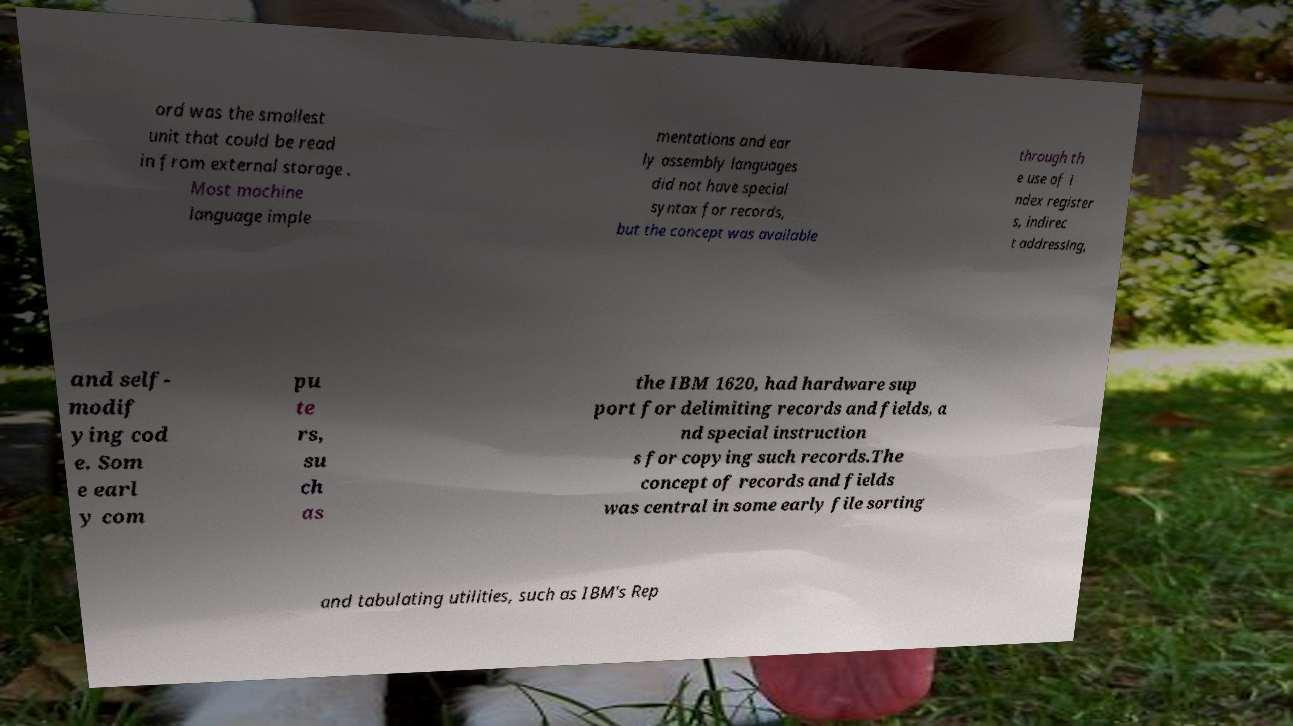For documentation purposes, I need the text within this image transcribed. Could you provide that? ord was the smallest unit that could be read in from external storage . Most machine language imple mentations and ear ly assembly languages did not have special syntax for records, but the concept was available through th e use of i ndex register s, indirec t addressing, and self- modif ying cod e. Som e earl y com pu te rs, su ch as the IBM 1620, had hardware sup port for delimiting records and fields, a nd special instruction s for copying such records.The concept of records and fields was central in some early file sorting and tabulating utilities, such as IBM's Rep 